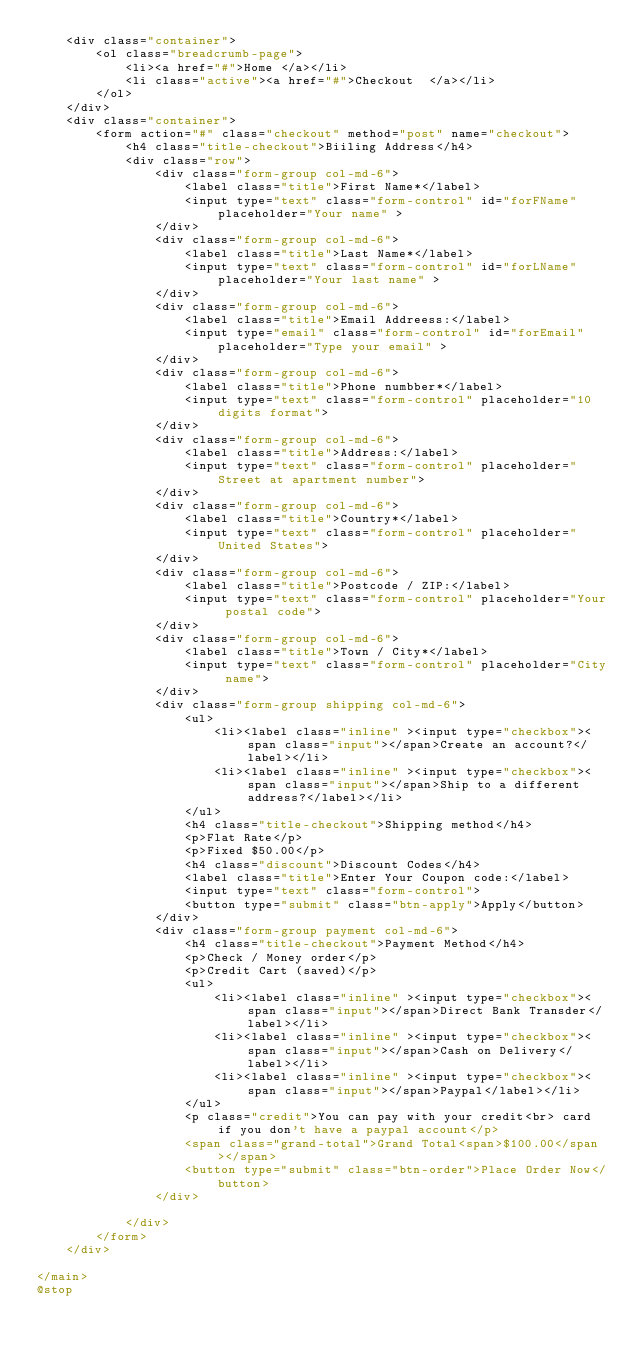<code> <loc_0><loc_0><loc_500><loc_500><_PHP_>    <div class="container">
        <ol class="breadcrumb-page">
            <li><a href="#">Home </a></li>
            <li class="active"><a href="#">Checkout  </a></li>
        </ol>
    </div>
    <div class="container">
        <form action="#" class="checkout" method="post" name="checkout">
            <h4 class="title-checkout">Biiling Address</h4>
            <div class="row">
                <div class="form-group col-md-6">   
                    <label class="title">First Name*</label> 
                    <input type="text" class="form-control" id="forFName" placeholder="Your name" >
                </div>
                <div class="form-group col-md-6">   
                    <label class="title">Last Name*</label> 
                    <input type="text" class="form-control" id="forLName" placeholder="Your last name" >
                </div>
                <div class="form-group col-md-6">
                    <label class="title">Email Addreess:</label>
                    <input type="email" class="form-control" id="forEmail" placeholder="Type your email" >
                </div>
                <div class="form-group col-md-6">
                    <label class="title">Phone numbber*</label>
                    <input type="text" class="form-control" placeholder="10 digits format">
                </div>
                <div class="form-group col-md-6">
                    <label class="title">Address:</label>
                    <input type="text" class="form-control" placeholder="Street at apartment number">
                </div>
                <div class="form-group col-md-6">
                    <label class="title">Country*</label>
                    <input type="text" class="form-control" placeholder="United States">
                </div>
                <div class="form-group col-md-6">
                    <label class="title">Postcode / ZIP:</label>
                    <input type="text" class="form-control" placeholder="Your postal code">
                </div>
                <div class="form-group col-md-6">
                    <label class="title">Town / City*</label>
                    <input type="text" class="form-control" placeholder="City name">
                </div>
                <div class="form-group shipping col-md-6">
                    <ul>
                        <li><label class="inline" ><input type="checkbox"><span class="input"></span>Create an account?</label></li>
                        <li><label class="inline" ><input type="checkbox"><span class="input"></span>Ship to a different address?</label></li>
                    </ul>
                    <h4 class="title-checkout">Shipping method</h4>
                    <p>Flat Rate</p>
                    <p>Fixed $50.00</p>
                    <h4 class="discount">Discount Codes</h4>
                    <label class="title">Enter Your Coupon code:</label>
                    <input type="text" class="form-control">
                    <button type="submit" class="btn-apply">Apply</button>
                </div>
                <div class="form-group payment col-md-6">
                    <h4 class="title-checkout">Payment Method</h4>
                    <p>Check / Money order</p>
                    <p>Credit Cart (saved)</p>
                    <ul>
                        <li><label class="inline" ><input type="checkbox"><span class="input"></span>Direct Bank Transder</label></li>
                        <li><label class="inline" ><input type="checkbox"><span class="input"></span>Cash on Delivery</label></li>
                        <li><label class="inline" ><input type="checkbox"><span class="input"></span>Paypal</label></li>
                    </ul>
                    <p class="credit">You can pay with your credit<br> card if you don't have a paypal account</p>
                    <span class="grand-total">Grand Total<span>$100.00</span></span>
                    <button type="submit" class="btn-order">Place Order Now</button>
                </div>
                
            </div>
        </form>
    </div>
    
</main>
@stop</code> 